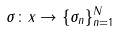Convert formula to latex. <formula><loc_0><loc_0><loc_500><loc_500>\sigma \colon x \to \{ \sigma _ { n } \} ^ { N } _ { n = 1 }</formula> 